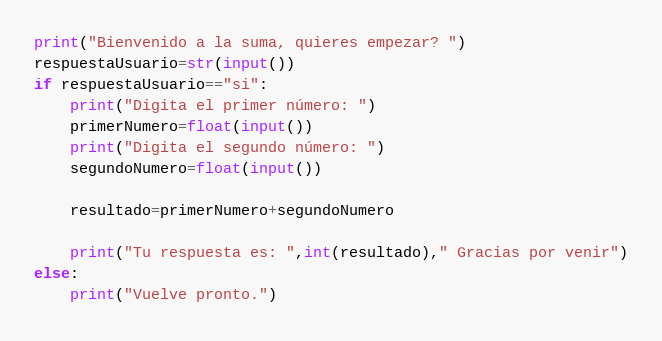<code> <loc_0><loc_0><loc_500><loc_500><_Python_>print("Bienvenido a la suma, quieres empezar? ")
respuestaUsuario=str(input())
if respuestaUsuario=="si":
    print("Digita el primer número: ")
    primerNumero=float(input())
    print("Digita el segundo número: ")
    segundoNumero=float(input())

    resultado=primerNumero+segundoNumero

    print("Tu respuesta es: ",int(resultado)," Gracias por venir")
else:
    print("Vuelve pronto.")
</code> 